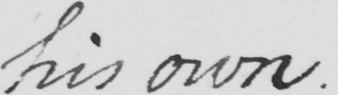What text is written in this handwritten line? his own . 